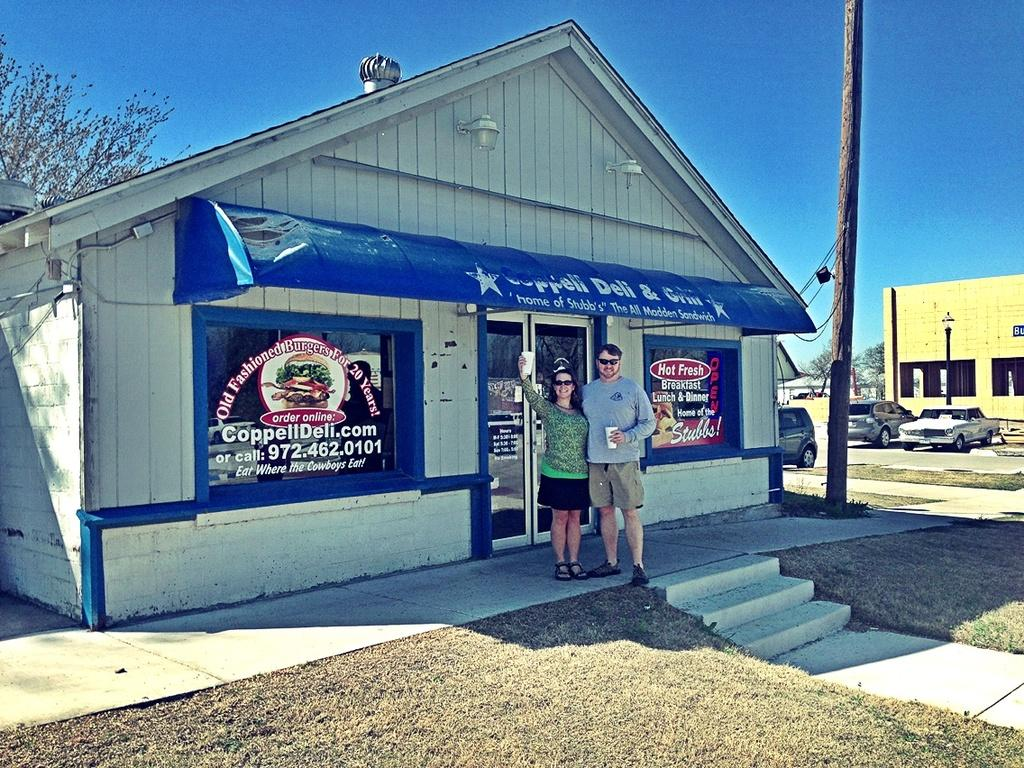How many people are present in the image? There are two people, a man and a woman, present in the image. What are the man and woman doing in the image? The man and woman are standing on the floor and smiling. What can be seen in the background of the image? There are buildings, trees, and the sky visible in the background of the image. What architectural feature is present in the image? There are steps in the image. What is on the ground in the image? There are cars on the ground in the image. What type of oil can be seen dripping from the rod in the image? There is no rod or oil present in the image. What are the scissors used for in the image? There are no scissors present in the image. 